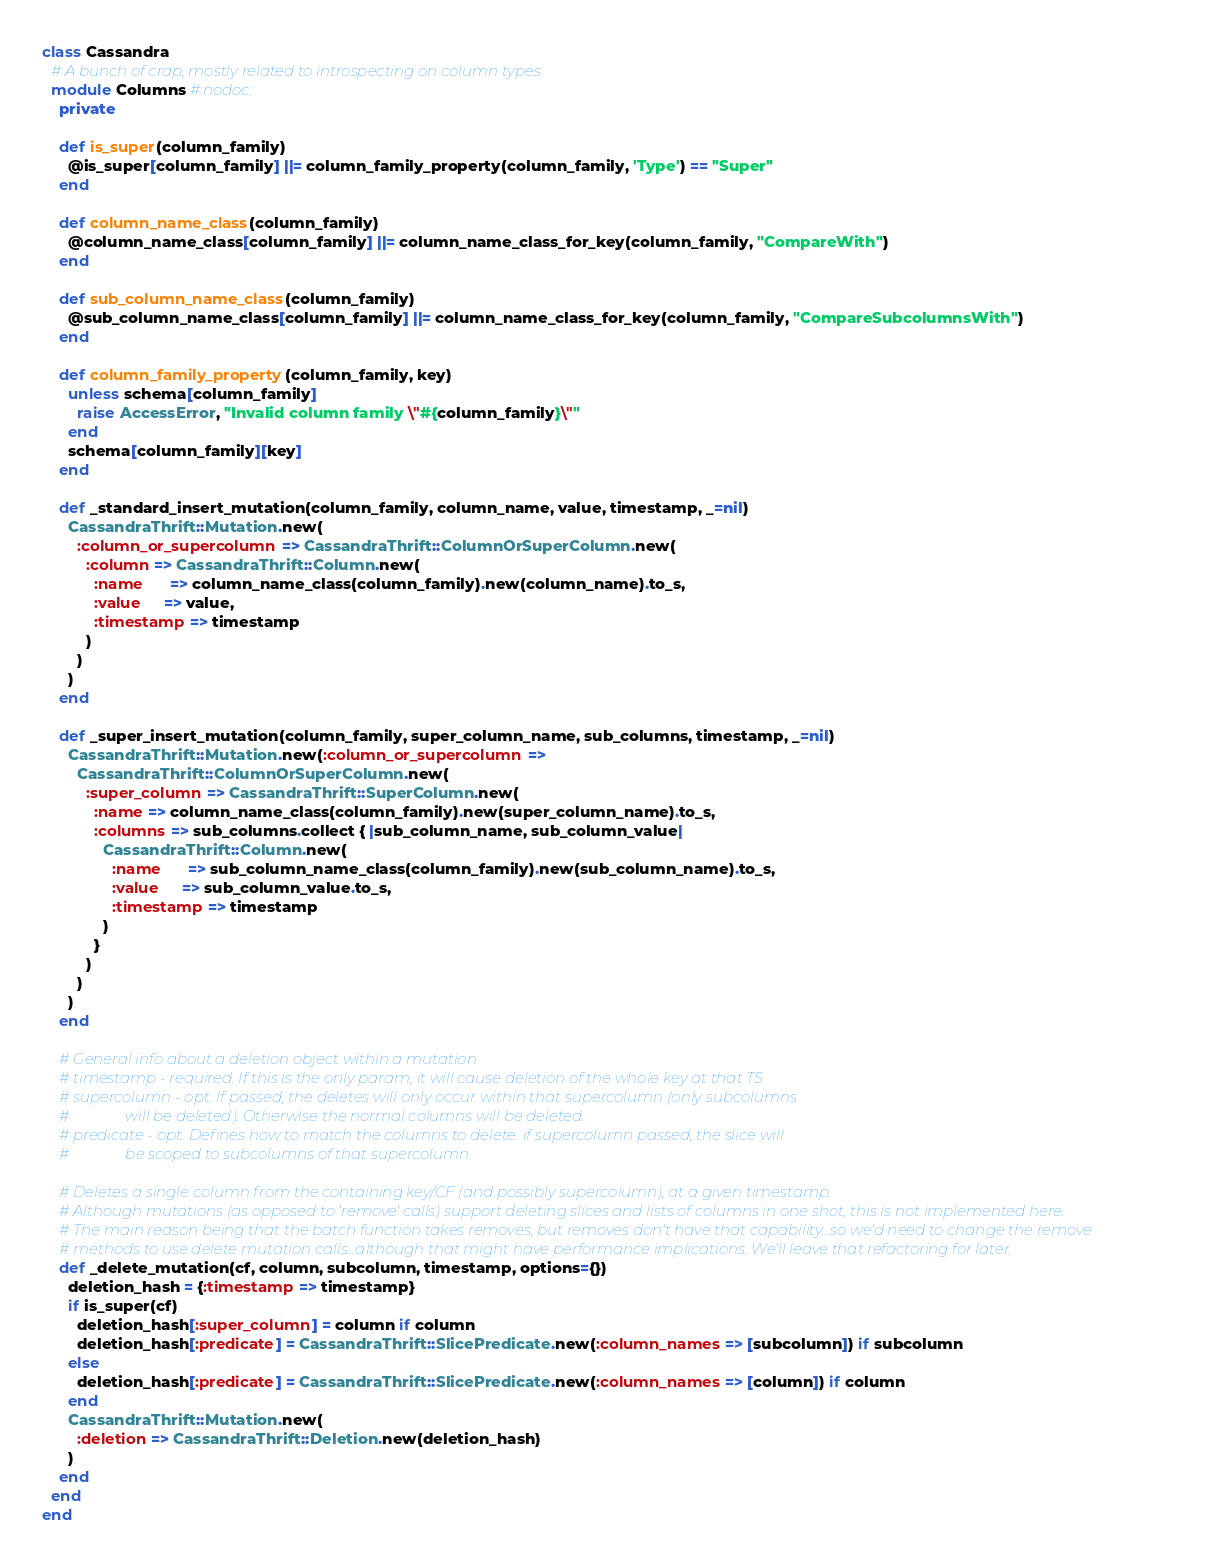Convert code to text. <code><loc_0><loc_0><loc_500><loc_500><_Ruby_>class Cassandra
  # A bunch of crap, mostly related to introspecting on column types
  module Columns #:nodoc:
    private

    def is_super(column_family)
      @is_super[column_family] ||= column_family_property(column_family, 'Type') == "Super"
    end

    def column_name_class(column_family)
      @column_name_class[column_family] ||= column_name_class_for_key(column_family, "CompareWith")
    end

    def sub_column_name_class(column_family)
      @sub_column_name_class[column_family] ||= column_name_class_for_key(column_family, "CompareSubcolumnsWith")
    end

    def column_family_property(column_family, key)
      unless schema[column_family]
        raise AccessError, "Invalid column family \"#{column_family}\""
      end
      schema[column_family][key]
    end

    def _standard_insert_mutation(column_family, column_name, value, timestamp, _=nil)
      CassandraThrift::Mutation.new(
        :column_or_supercolumn => CassandraThrift::ColumnOrSuperColumn.new(
          :column => CassandraThrift::Column.new(
            :name      => column_name_class(column_family).new(column_name).to_s,
            :value     => value,
            :timestamp => timestamp
          )
        )
      )
    end

    def _super_insert_mutation(column_family, super_column_name, sub_columns, timestamp, _=nil)
      CassandraThrift::Mutation.new(:column_or_supercolumn => 
        CassandraThrift::ColumnOrSuperColumn.new(
          :super_column => CassandraThrift::SuperColumn.new(
            :name => column_name_class(column_family).new(super_column_name).to_s,
            :columns => sub_columns.collect { |sub_column_name, sub_column_value|
              CassandraThrift::Column.new(
                :name      => sub_column_name_class(column_family).new(sub_column_name).to_s,
                :value     => sub_column_value.to_s,
                :timestamp => timestamp
              )
            }
          )
        )
      )
    end

    # General info about a deletion object within a mutation
    # timestamp - required. If this is the only param, it will cause deletion of the whole key at that TS
    # supercolumn - opt. If passed, the deletes will only occur within that supercolumn (only subcolumns 
    #               will be deleted). Otherwise the normal columns will be deleted.
    # predicate - opt. Defines how to match the columns to delete. if supercolumn passed, the slice will 
    #               be scoped to subcolumns of that supercolumn.
    
    # Deletes a single column from the containing key/CF (and possibly supercolumn), at a given timestamp. 
    # Although mutations (as opposed to 'remove' calls) support deleting slices and lists of columns in one shot, this is not implemented here.
    # The main reason being that the batch function takes removes, but removes don't have that capability...so we'd need to change the remove
    # methods to use delete mutation calls...although that might have performance implications. We'll leave that refactoring for later.
    def _delete_mutation(cf, column, subcolumn, timestamp, options={})
      deletion_hash = {:timestamp => timestamp}
      if is_super(cf)
        deletion_hash[:super_column] = column if column
        deletion_hash[:predicate] = CassandraThrift::SlicePredicate.new(:column_names => [subcolumn]) if subcolumn
      else
        deletion_hash[:predicate] = CassandraThrift::SlicePredicate.new(:column_names => [column]) if column
      end
      CassandraThrift::Mutation.new(
        :deletion => CassandraThrift::Deletion.new(deletion_hash)
      )
    end
  end
end
</code> 